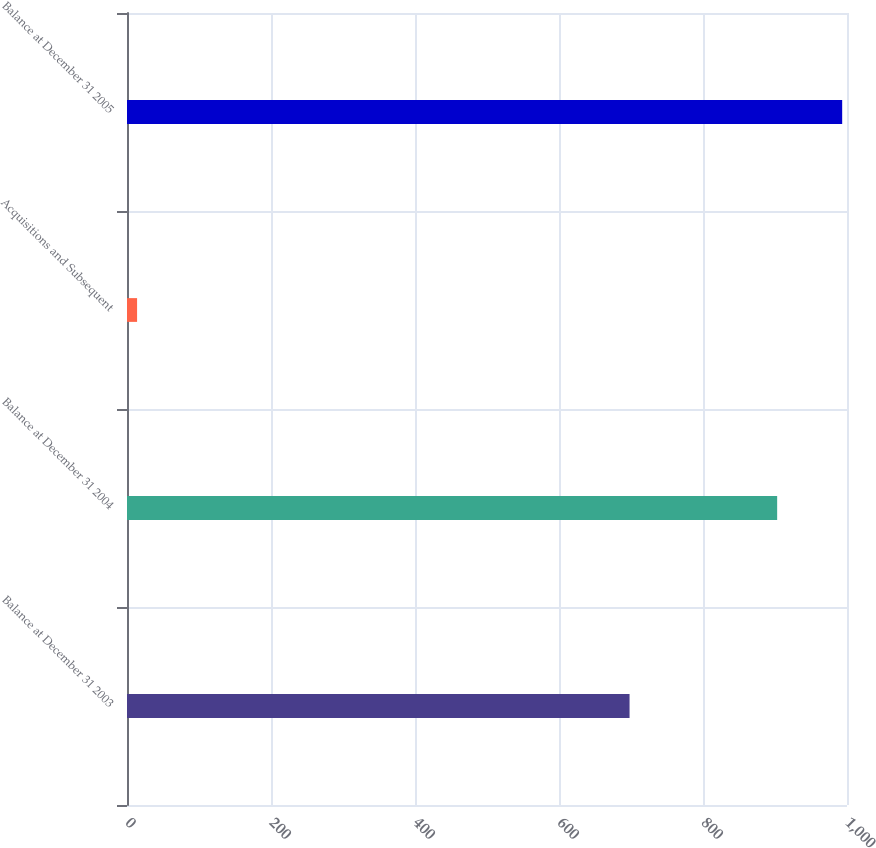<chart> <loc_0><loc_0><loc_500><loc_500><bar_chart><fcel>Balance at December 31 2003<fcel>Balance at December 31 2004<fcel>Acquisitions and Subsequent<fcel>Balance at December 31 2005<nl><fcel>698<fcel>903<fcel>14<fcel>993.3<nl></chart> 